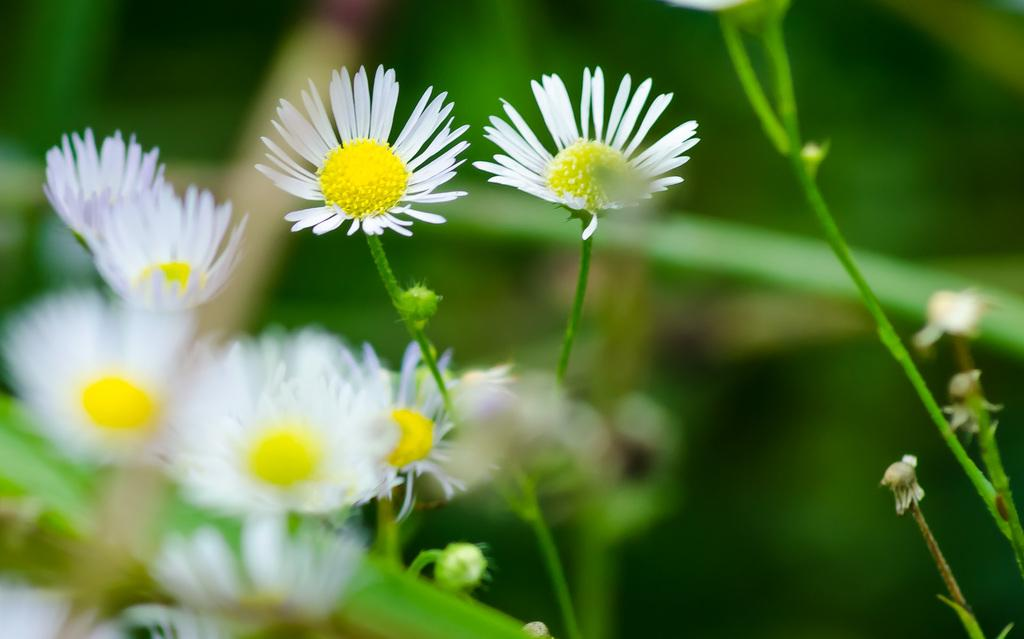What type of flora is present in the image? There are flowers in the image. What color are the flowers? The flowers are white in color. What can be seen behind the flowers in the image? There is a green background in the image. How is the background depicted in the image? The background is blurred. What is the title of the book that the flowers are holding in the image? There is no book or any text present in the image, so there is no title to reference. 